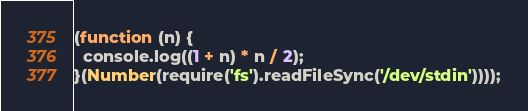<code> <loc_0><loc_0><loc_500><loc_500><_JavaScript_>(function (n) {
  console.log((1 + n) * n / 2);
}(Number(require('fs').readFileSync('/dev/stdin'))));
</code> 